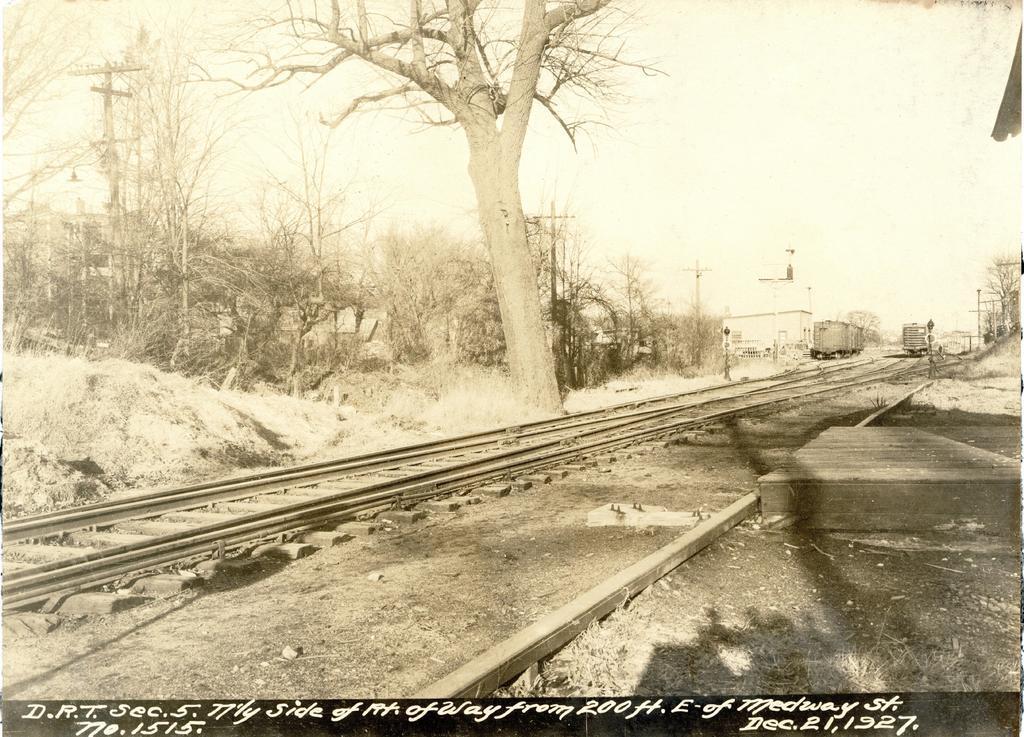How would you summarize this image in a sentence or two? In the given picture there is a railway track and a tree. In the background there are some trees and train bogies located. There is a building beside the train bogie. In the background we can observe sky here. 